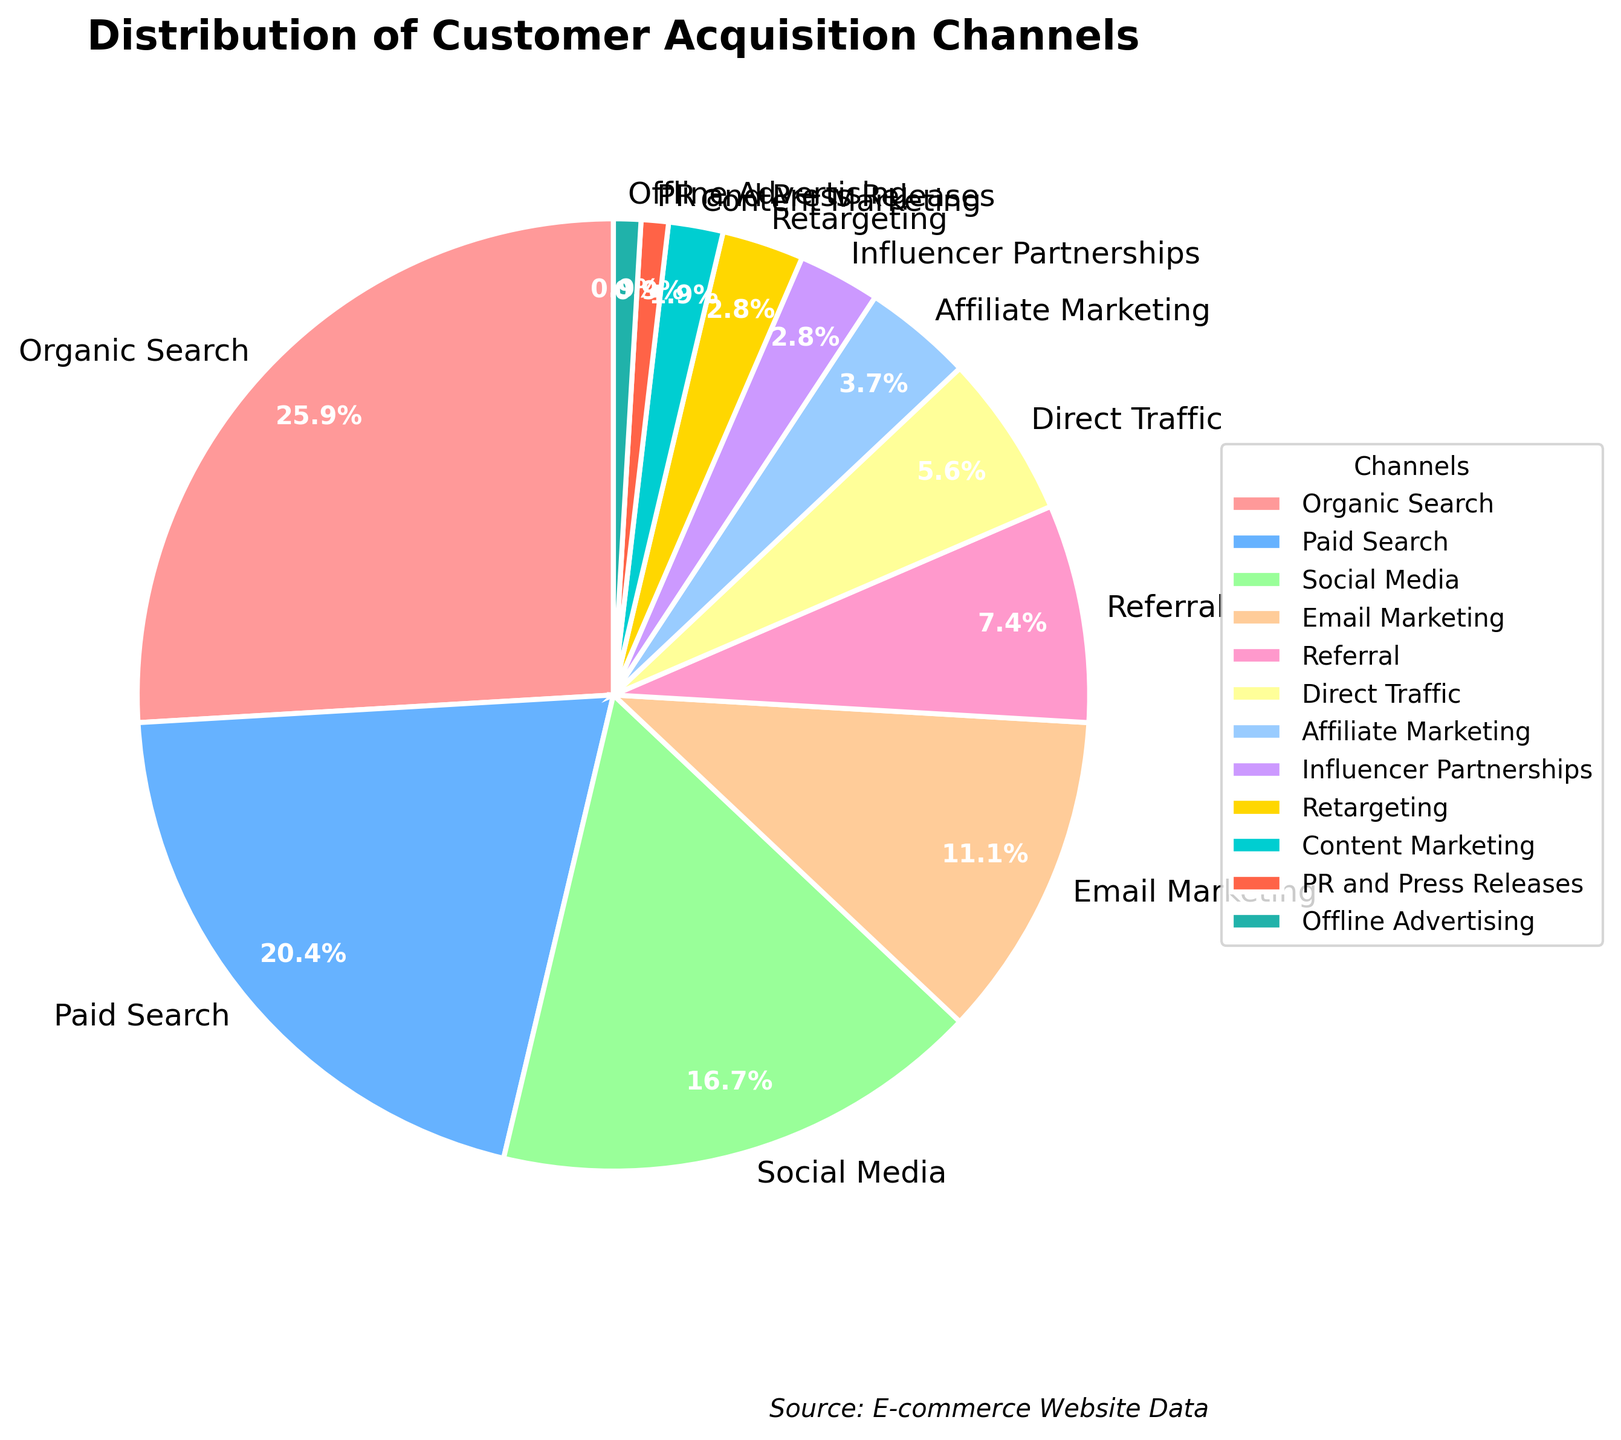What is the most effective customer acquisition channel based on the chart? According to the pie chart, the channel with the highest percentage is Organic Search at 28%.
Answer: Organic Search Which channels together account for more than 50% of customer acquisition? Adding the percentages of the top channels: Organic Search (28%) + Paid Search (22%) gives a total of 50%. So, Organic Search and Paid Search together account for 50%. Social Media also adds to the total.
Answer: Organic Search, Paid Search, Social Media How does Social Media compare to Paid Search in terms of the percentage of customer acquisition? The percentage for Social Media is 18%, while Paid Search is 22%. Paid Search is higher.
Answer: Paid Search is higher What’s the combined percentage of Email Marketing and Affiliate Marketing? The percentages for Email Marketing and Affiliate Marketing are 12% and 4% respectively. Adding them together gives 12 + 4 = 16%.
Answer: 16% Which channels contribute the least to customer acquisitions and what is their combined percentage? The channels with the least percentages are PR and Press Releases and Offline Advertising, both at 1% each. Combining them gives 1 + 1 = 2%.
Answer: PR and Press Releases, Offline Advertising; 2% How much more effective is Organic Search compared to Retargeting? Organic Search accounts for 28% while Retargeting accounts for 3%. The difference is 28 - 3 = 25%.
Answer: 25% What is the total percentage for the channels with less than 5% acquisition? Adding the percentages for Affiliate Marketing (4%), Influencer Partnerships (3%), Retargeting (3%), Content Marketing (2%), PR and Press Releases (1%), and Offline Advertising (1%) gives a total of 4 + 3 + 3 + 2 + 1 + 1 = 14%.
Answer: 14% Is Direct Traffic or Referral responsible for more customer acquisition? Direct Traffic accounts for 6%, while Referral accounts for 8%. Referral is higher.
Answer: Referral is higher By what percentage does Email Marketing exceed Direct Traffic for customer acquisitions? Email Marketing is at 12% while Direct Traffic is at 6%. The difference is 12 - 6 = 6%.
Answer: 6% What percentage of customer acquisition channels fall under 10%? The channels under 10% are Referral (8%), Direct Traffic (6%), Affiliate Marketing (4%), Influencer Partnerships (3%), Retargeting (3%), Content Marketing (2%), PR and Press Releases (1%), and Offline Advertising (1%). Adding them gives 8 + 6 + 4 + 3 + 3 + 2 + 1 + 1 = 28%.
Answer: 28% 